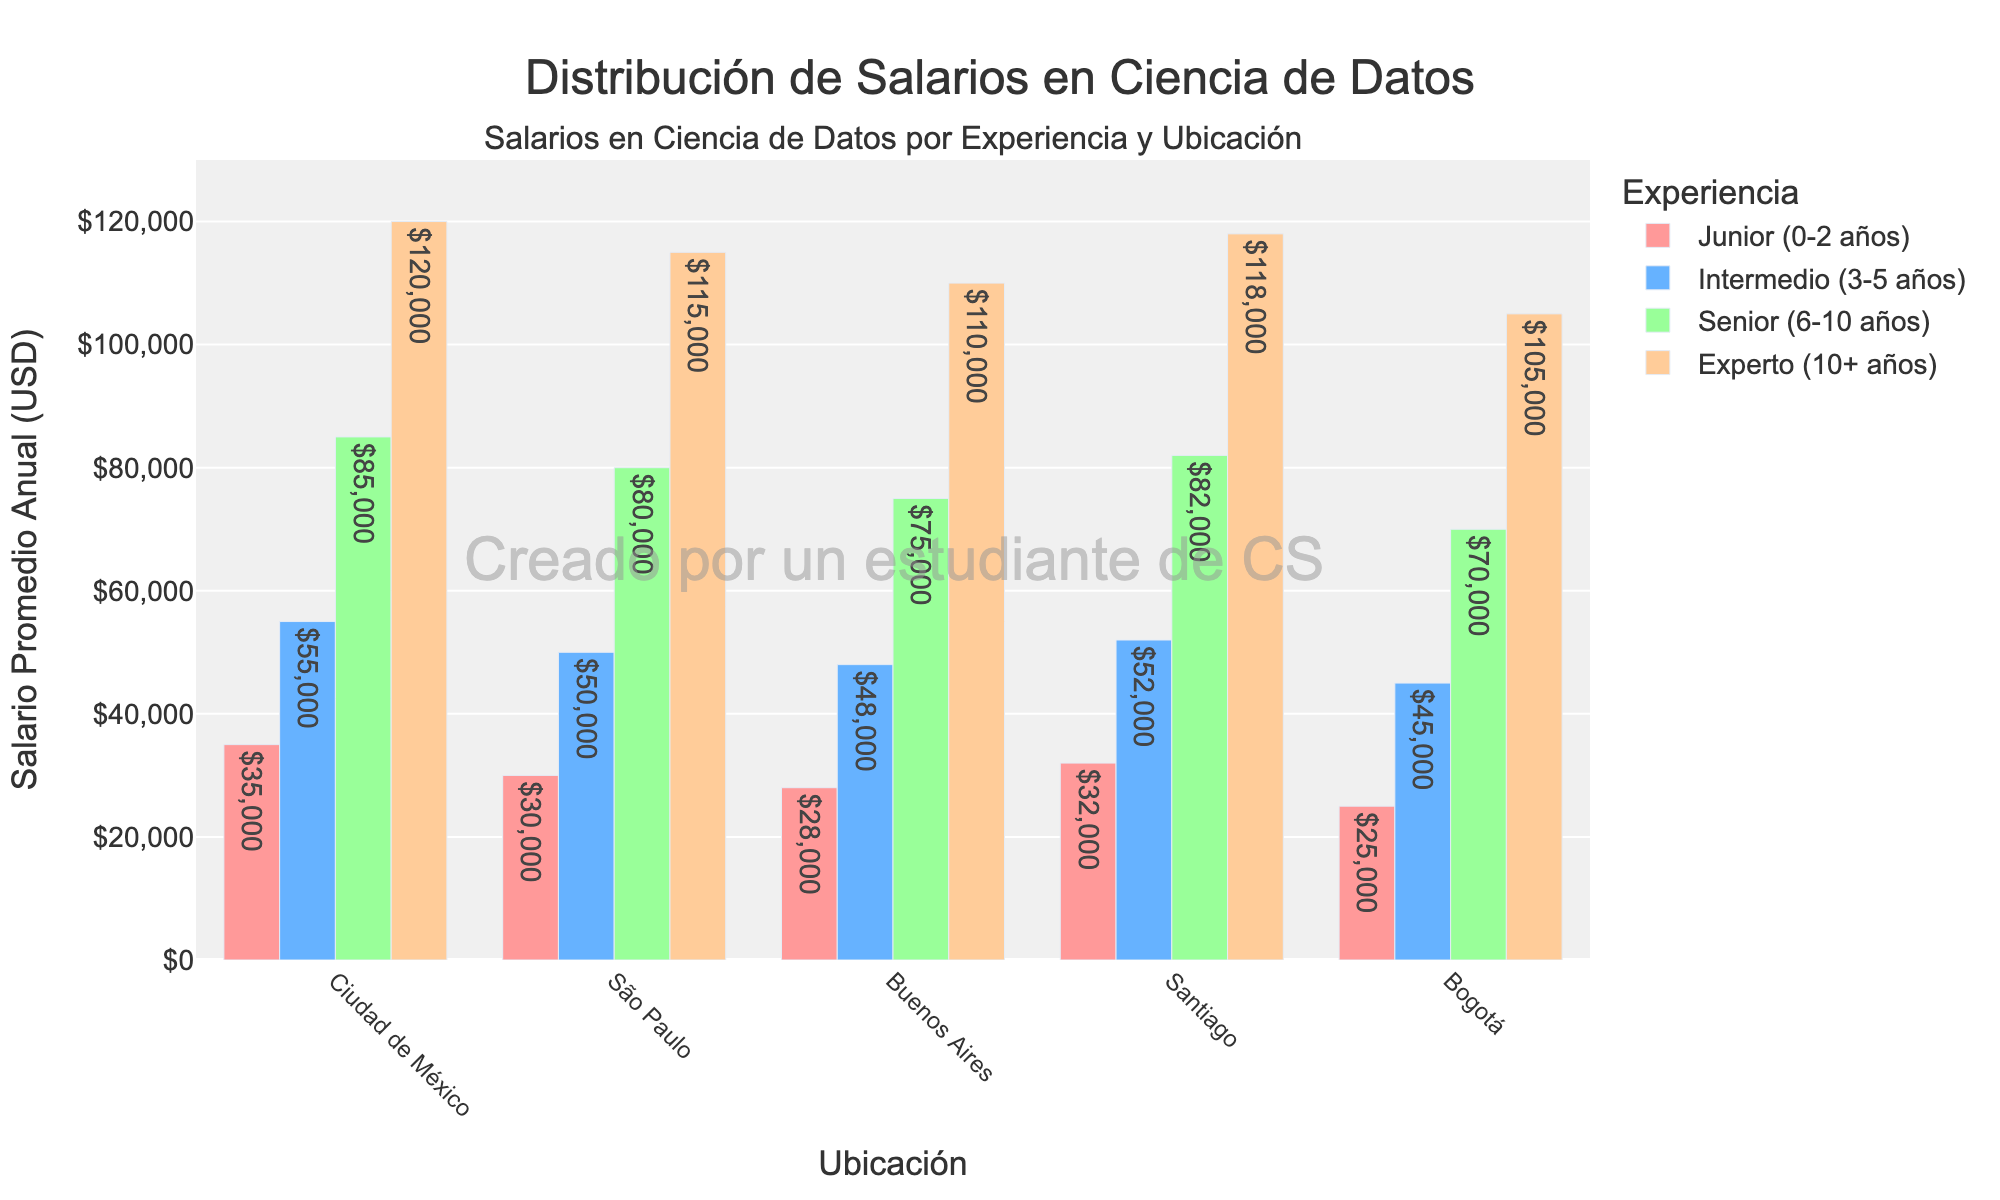What is the average salary for Junior positions across all locations? To calculate the average salary, add the salaries of Junior positions from all locations and divide by the number of locations: (35000 + 30000 + 28000 + 32000 + 25000) / 5 = 150000 / 5 = 30000
Answer: 30000 Which location offers the highest average salary for Senior positions? Check the bar heights for Senior positions across all locations. The highest bar (85000) corresponds to Ciudad de México.
Answer: Ciudad de México How much more does an Expert in Ciudad de México earn compared to an Expert in Bogotá? Subtract the salary of an Expert in Bogotá from the salary of an Expert in Ciudad de México: 120000 - 105000 = 15000
Answer: 15000 What is the difference in salary for Intermedio positions between the highest and lowest paying locations? Find the highest and lowest salaries for Intermedio positions and subtract the lowest from the highest: 55000 - 45000 = 10000
Answer: 10000 What location has the lowest average salary for Junior positions and what is the salary? Identify the lowest bar height for Junior positions which is 25000 in Bogotá.
Answer: Bogotá, 25000 How does the salary of a Senior in Buenos Aires compare to that of an Intermedio in Ciudad de México? Subtract the salary of an Intermedio in Ciudad de México from the salary of a Senior in Buenos Aires: 75000 - 55000 = 20000
Answer: 20000 Which location offers more salary for a Senior compared to an Experienced individual in the same location? Compare the heights of the bars for Senior and Experto for each location. None of the locations offer a higher salary for Seniors than for Expertos, as Expertos earn more in all cases.
Answer: None Calculate the average salary for all Expert positions across all locations. Add up all the Expert salaries and divide by the number of locations: (120000 + 115000 + 110000 + 118000 + 105000) / 5 = 568000 / 5 = 113600
Answer: 113600 What is the total salary sum for all locations combined for Intermedio positions? Sum the salaries for all Intermedio positions across all locations: 55000 + 50000 + 48000 + 52000 + 45000 = 250000
Answer: 250000 